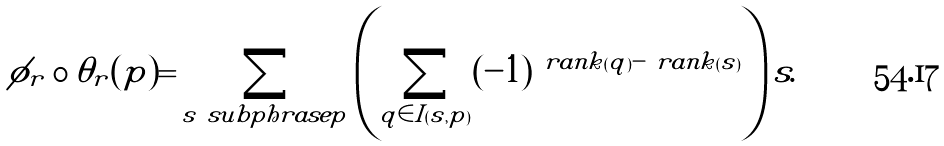<formula> <loc_0><loc_0><loc_500><loc_500>\phi _ { r } \circ \theta _ { r } ( p ) = \sum _ { s \ s u b p h r a s e p } \left ( \sum _ { q \in I ( s , p ) } ( - 1 ) ^ { \ r a n k ( q ) - \ r a n k ( s ) } \right ) s .</formula> 